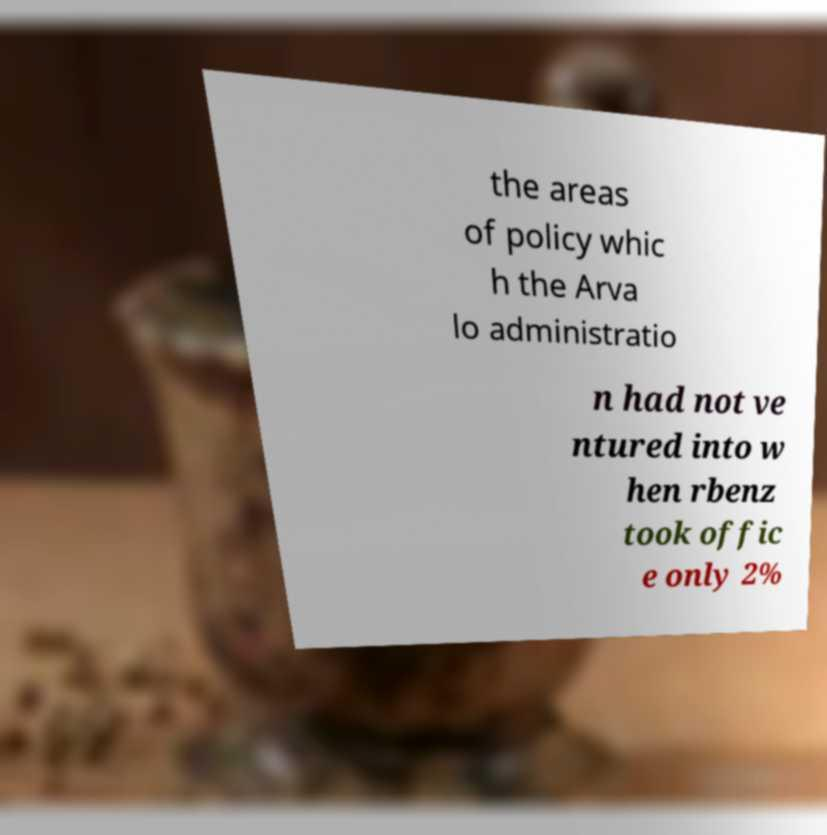Please read and relay the text visible in this image. What does it say? the areas of policy whic h the Arva lo administratio n had not ve ntured into w hen rbenz took offic e only 2% 